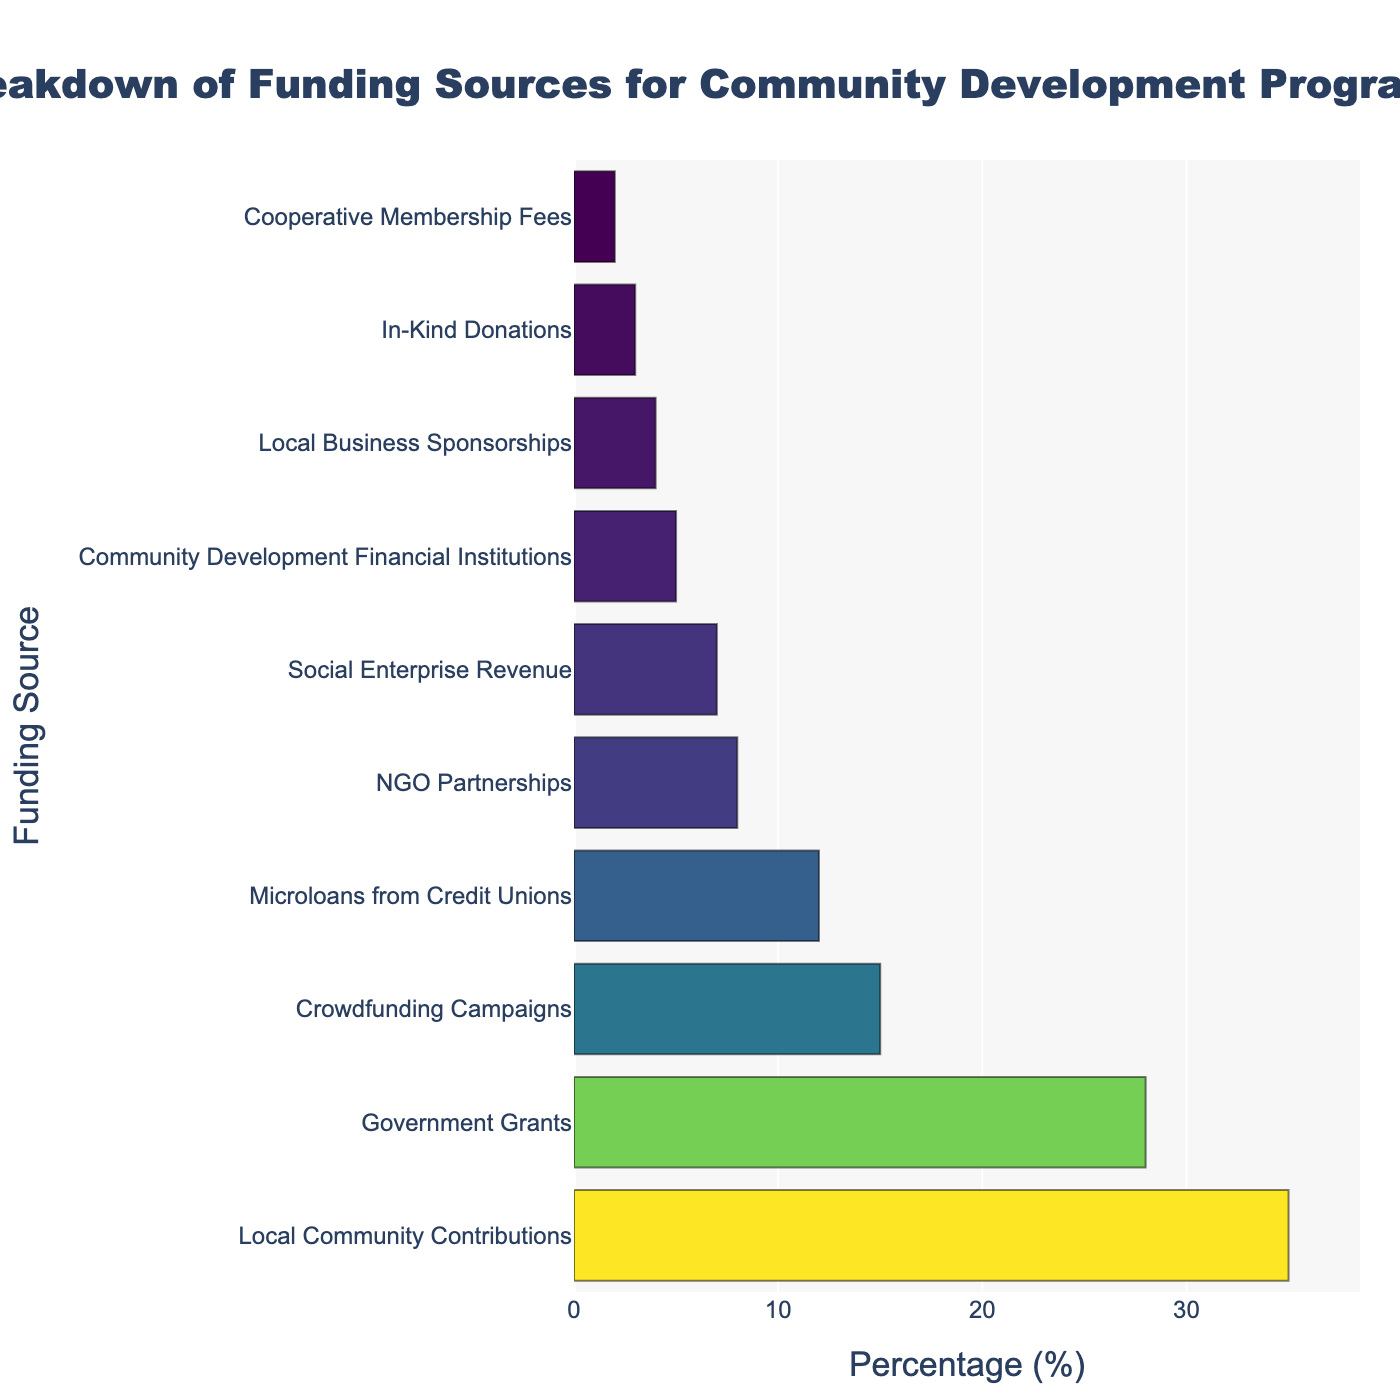What percentage of funding comes from local contributions? By examining the bar labeled "Local Community Contributions," we see that it reaches the 35% mark on the x-axis.
Answer: 35% Which funding source has the least contribution? By looking at the shortest bar, labeled "Cooperative Membership Fees," we see it ends at 2%.
Answer: Cooperative Membership Fees How much more funding do local community contributions provide compared to government grants? Local Community Contributions stand at 35%, and Government Grants at 28%. The difference is calculated as 35% - 28% = 7%.
Answer: 7% What is the combined percentage of funding from local contributions and crowdfunding campaigns? Local Community Contributions provide 35% and Crowdfunding Campaigns provide 15%. Their sum is 35% + 15% = 50%.
Answer: 50% Are microloans from credit unions more than double the percentage of community development financial institutions? Microloans from Credit Unions are at 12%, and Community Development Financial Institutions are at 5%. Checking the condition: 12% > 2 * 5%. It is true.
Answer: Yes Which funding source is closest in percentage to microloans from credit unions? Microloans from Credit Unions are at 12%. NGO Partnerships are at 8%, and Social Enterprise Revenue is at 7%, both lower. Government Grants at 28% and Local Community Contributions at 35% are higher. The closest is NGO Partnerships.
Answer: NGO Partnerships What is the average percentage of the three smallest contributors? The three smallest contributors are Cooperative Membership Fees (2%), In-Kind Donations (3%), and Local Business Sponsorships (4%). The average is calculated as (2% + 3% + 4%) / 3 = 3%.
Answer: 3% What is the color of the bar representing NGO partnerships? Following the Viridis color scale applied to the chart, the color ranges from yellow (highest percentage) to dark blue (lowest percentage). NGO Partnerships have a color between the two extremes, which falls in a greenish hue.
Answer: Greenish What is the ratio of funding from social enterprise revenue to crowdfunding campaigns? Social Enterprise Revenue is at 7%, and Crowdfunding Campaigns are at 15%. The ratio is 7/15, which simplifies to approximately 0.47.
Answer: 0.47 Is the contribution from local business sponsorships greater or less than social enterprise revenue? Local Business Sponsorships contribute 4%, while Social Enterprise Revenue is at 7%. Comparing the two, 4% < 7%.
Answer: Less 